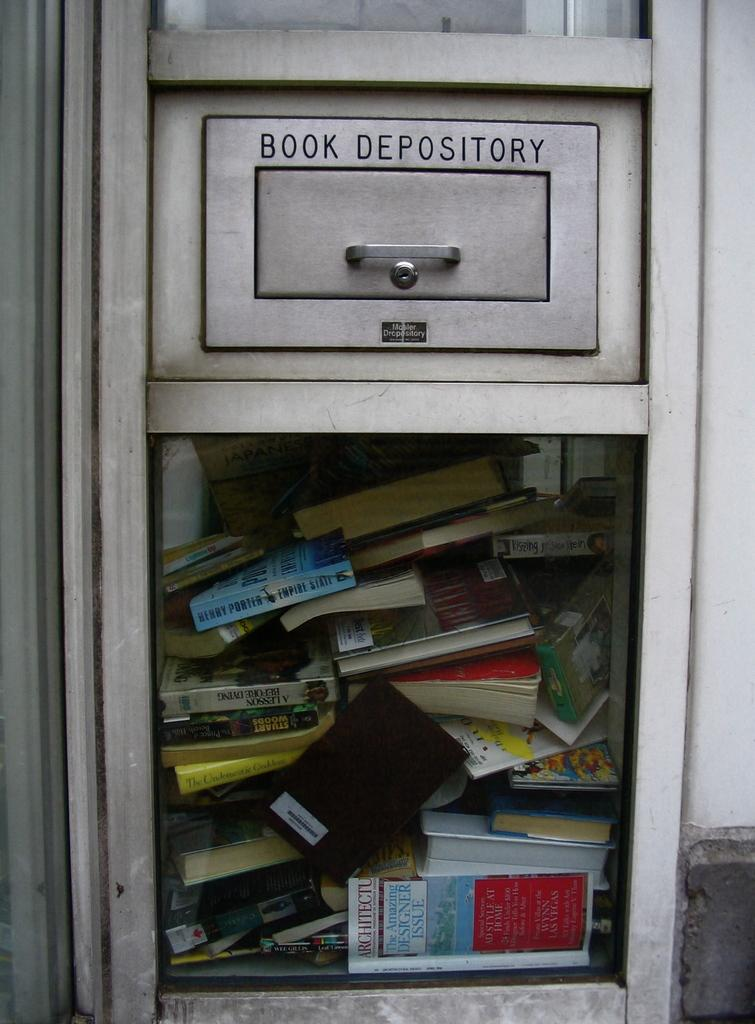<image>
Write a terse but informative summary of the picture. A book depository full of various used books. 